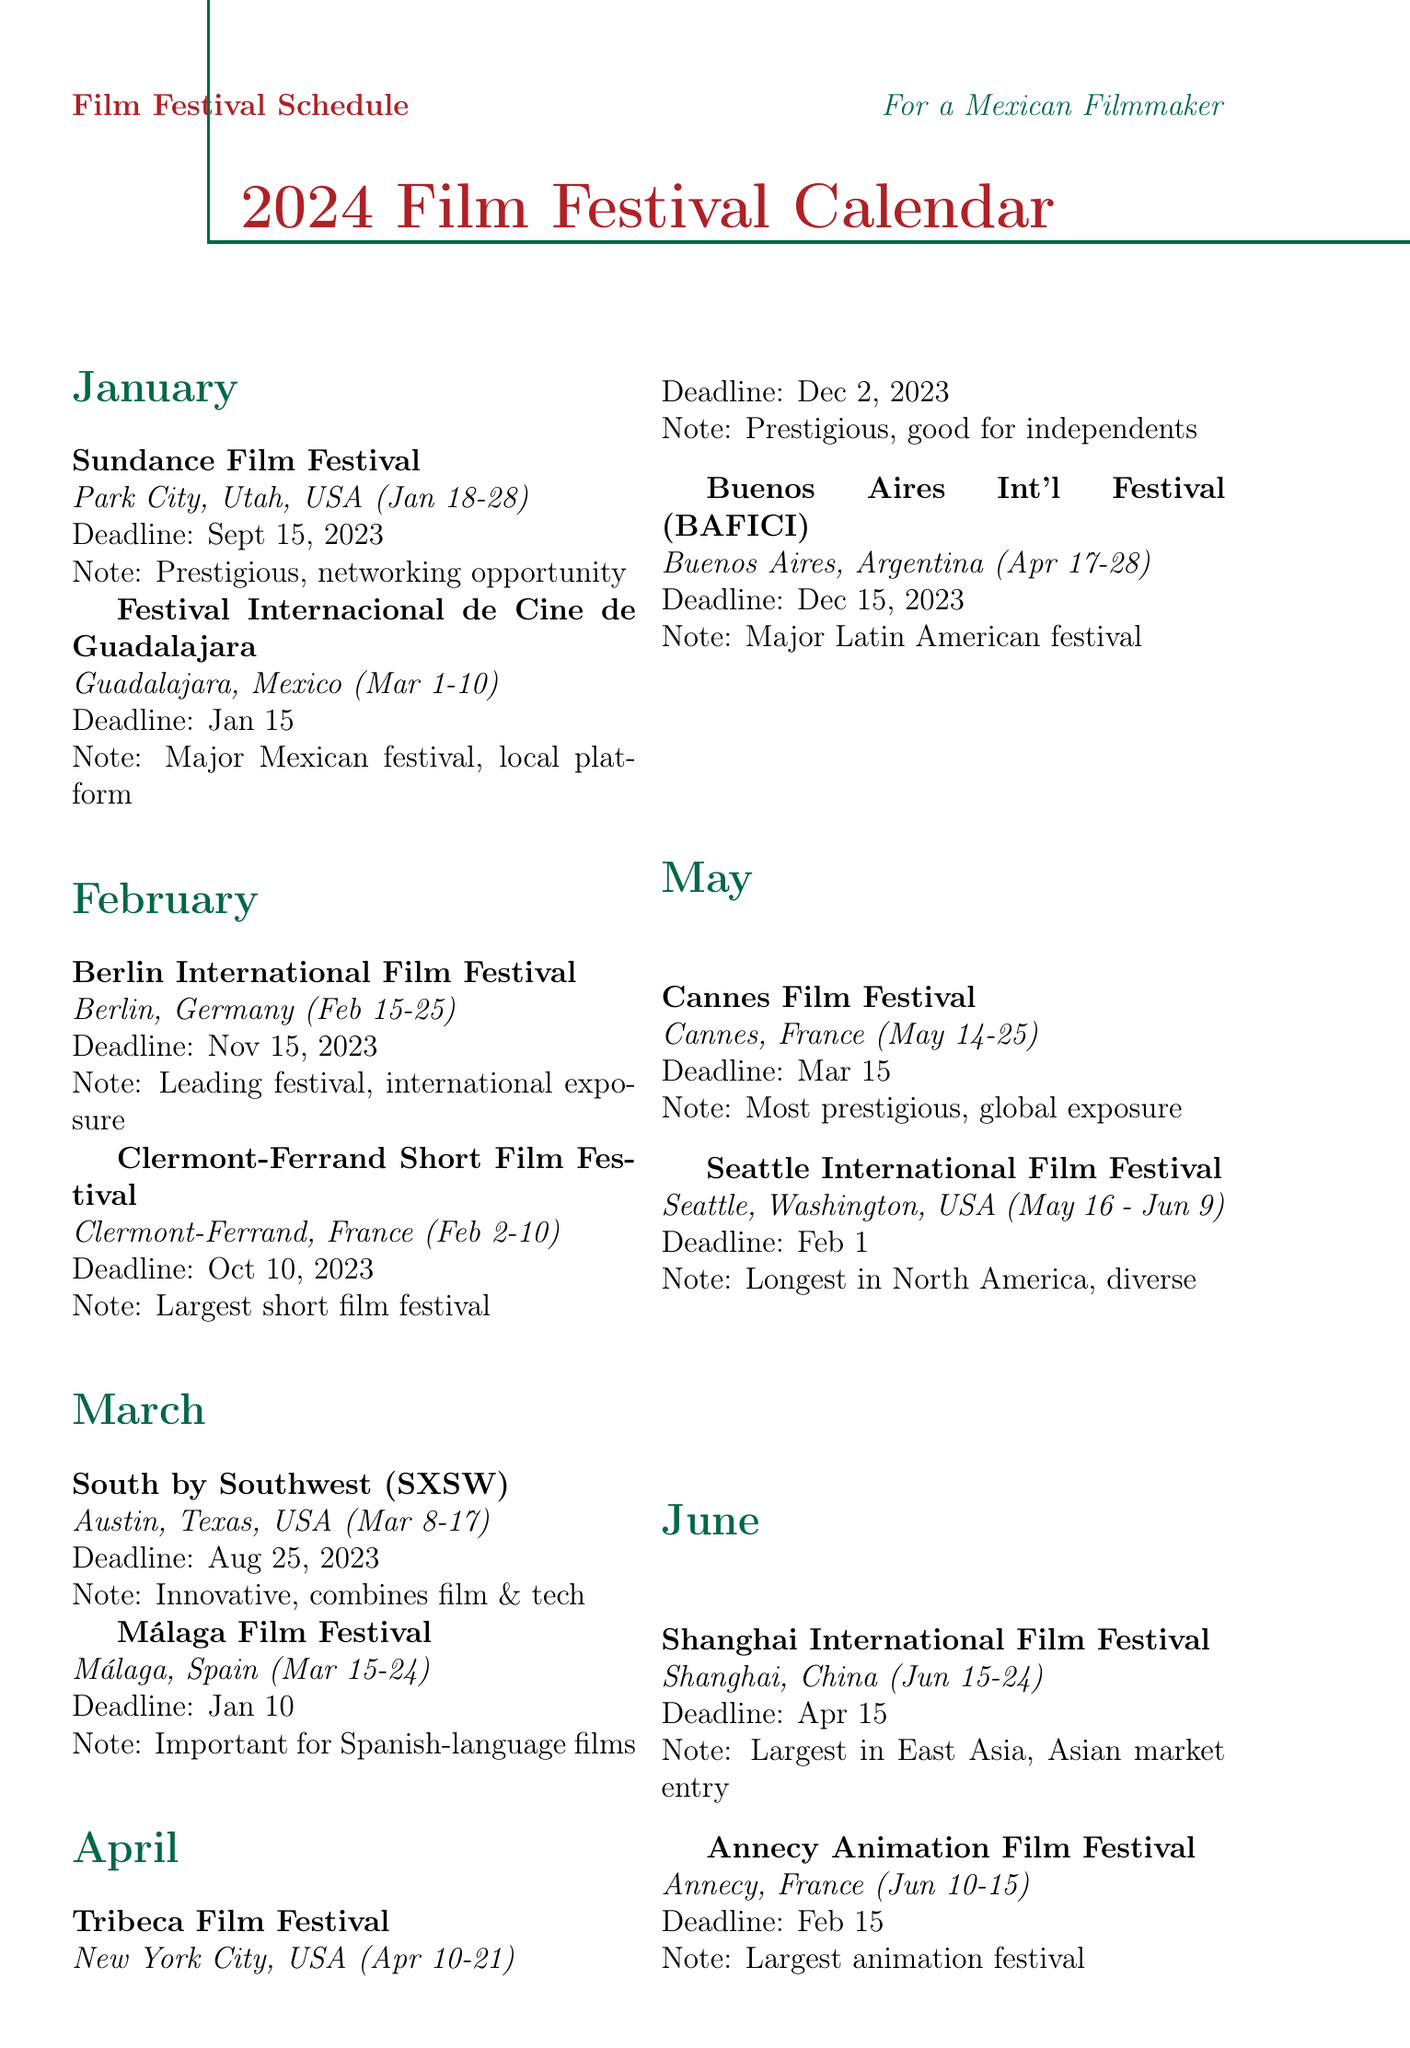what are the dates of the Sundance Film Festival? The Sundance Film Festival takes place from January 18-28.
Answer: January 18-28 what is the submission deadline for the Cannes Film Festival? The submission deadline for the Cannes Film Festival is March 15.
Answer: March 15 which festival is held in Guadalajara, Mexico? The festival held in Guadalajara, Mexico is the Festival Internacional de Cine de Guadalajara.
Answer: Festival Internacional de Cine de Guadalajara how many festivals are listed for June? There are two festivals listed for June in the document.
Answer: 2 what type of film festival is the Clermont-Ferrand International Short Film Festival? The Clermont-Ferrand International Short Film Festival is dedicated to short films.
Answer: short films which festival has the longest duration in the document? The longest film festival in North America is the Seattle International Film Festival, which lasts from May 16 to June 9.
Answer: Seattle International Film Festival what is the location of the Venice International Film Festival? The Venice International Film Festival is located in Venice, Italy.
Answer: Venice, Italy which festival is the premier showcase for Mexican cinema? The premier showcase for Mexican cinema is the Morelia International Film Festival.
Answer: Morelia International Film Festival what is the note about the AFI Fest? The AFI Fest is described as the premier US festival for international filmmakers.
Answer: premier US festival for international filmmakers 